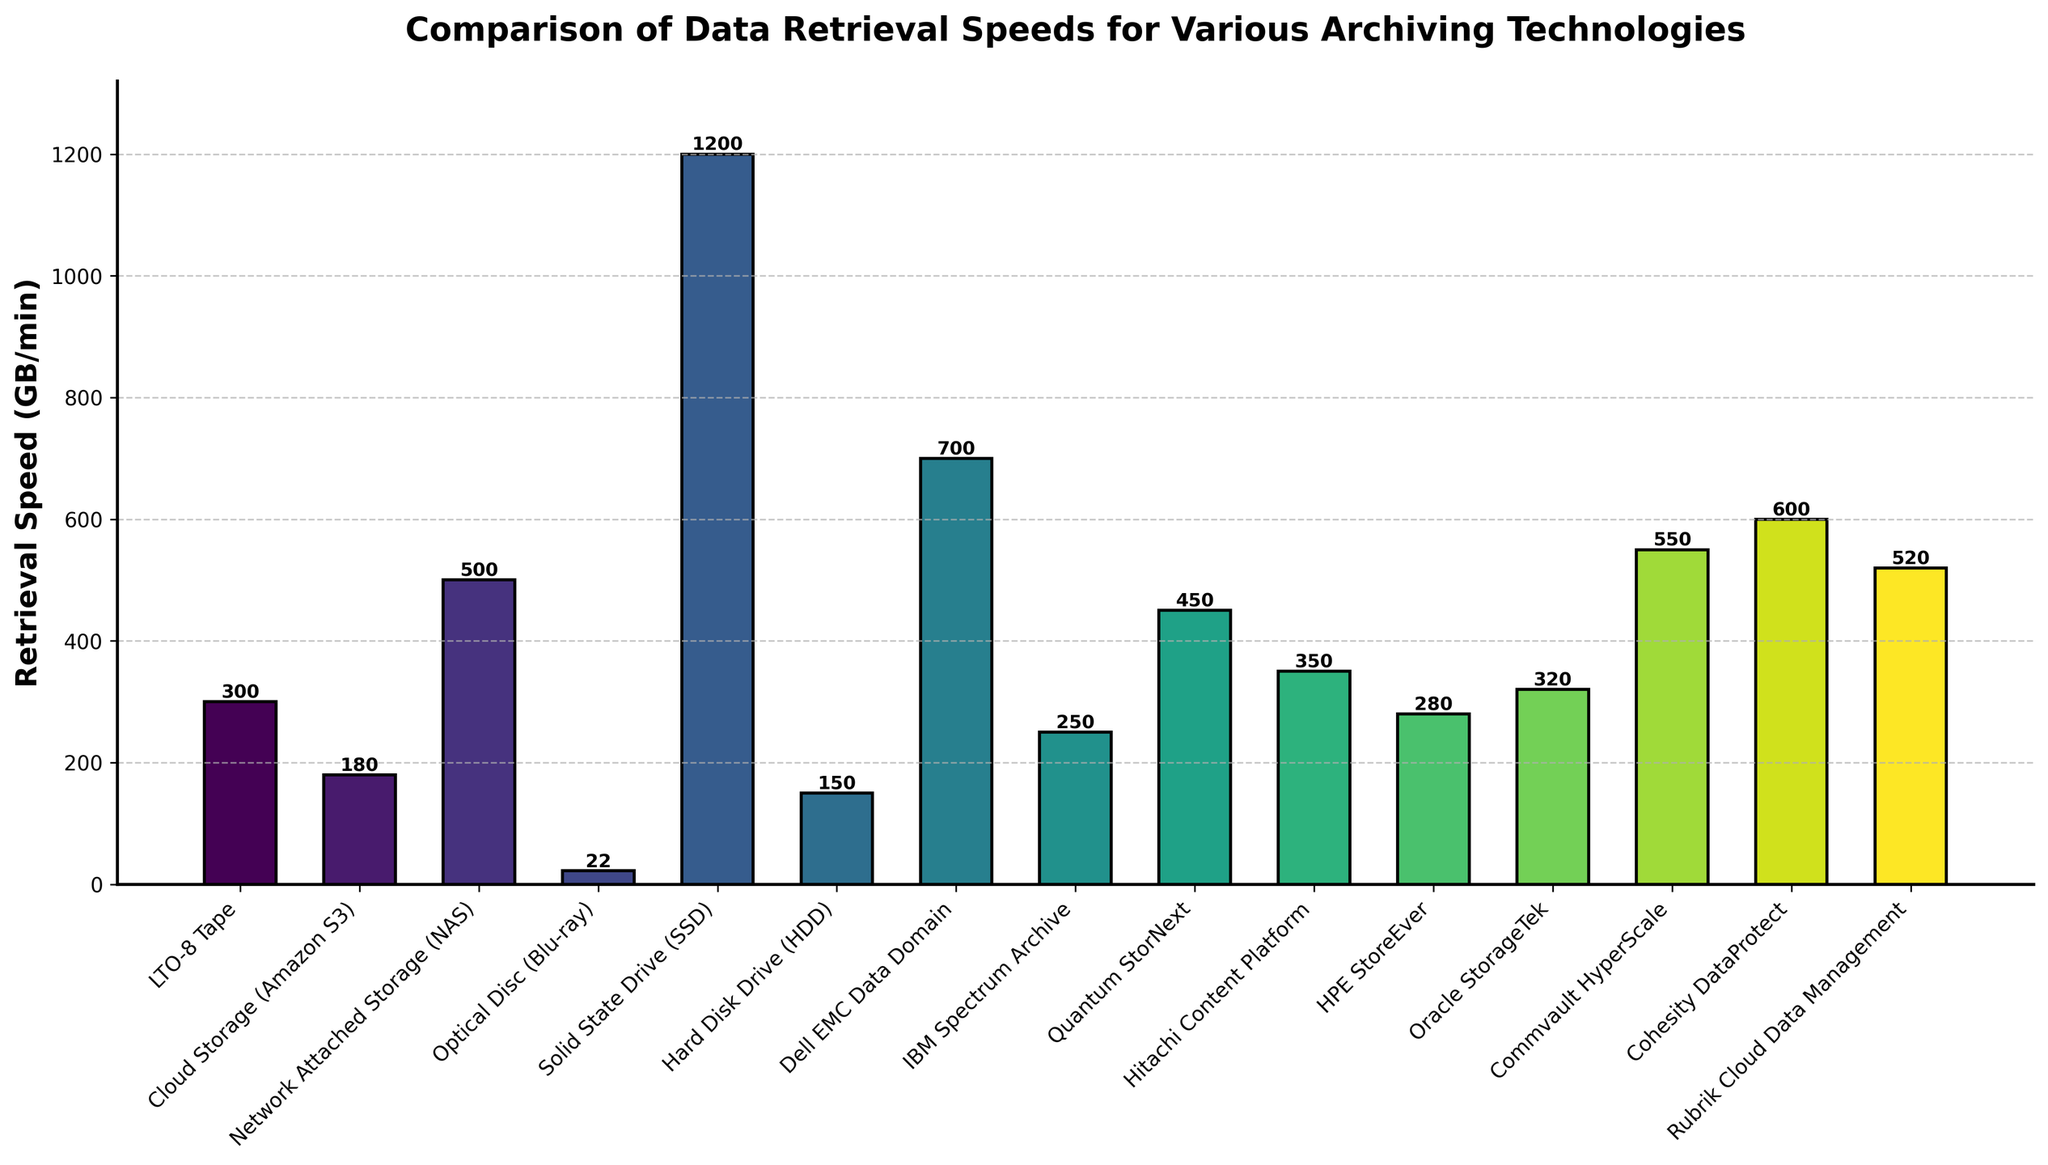What's the fastest data retrieval technology? The highest bar in the chart represents the fastest data retrieval technology. In this case, the Solid State Drive (SSD) has the tallest bar, indicating the highest retrieval speed.
Answer: Solid State Drive (SSD) What's the difference in retrieval speed between LTO-8 Tape and Cloud Storage (Amazon S3)? The LTO-8 Tape has a retrieval speed of 300 GB/min and Cloud Storage (Amazon S3) has 180 GB/min. The difference is calculated by subtracting the smaller value from the larger one (300 - 180).
Answer: 120 GB/min What is the average retrieval speed among all technologies? To find the average, sum all the retrieval speeds and divide by the number of technologies. The sum is (300 + 180 + 500 + 22 + 1200 + 150 + 700 + 250 + 450 + 350 + 280 + 320 + 550 + 600 + 520) = 6372. There are 15 technologies, so the average is 6372 / 15.
Answer: 424.8 GB/min Which technology has a slightly lower retrieval speed than Dell EMC Data Domain? Dell EMC Data Domain has a speed of 700 GB/min. By examining the bars, the closest lower value is Quantum StorNext at 450 GB/min but Cohesity DataProtect at 600 GB/min is slightly lower.
Answer: Cohesity DataProtect Which technology has the lowest retrieval speed and what is its value? The shortest bar in the chart represents the technology with the lowest retrieval speed. The Optical Disc (Blu-ray) is the shortest bar, with a retrieval speed.
Answer: 22 GB/min How many technologies have a retrieval speed greater than 400 GB/min? Count the number of bars that are taller than the one representing 400 GB/min. These are Network Attached Storage (NAS), Solid State Drive (SSD), Dell EMC Data Domain, Quantum StorNext, Commvault HyperScale, Cohesity DataProtect, and Rubrik Cloud Data Management.
Answer: 7 Which has a higher retrieval speed: IBM Spectrum Archive or Hitachi Content Platform? Comparing the heights of their respective bars, Hitachi Content Platform is slightly taller than IBM Spectrum Archive.
Answer: Hitachi Content Platform What is the combined retrieval speed of Solid State Drive (SSD) and Dell EMC Data Domain? The retrieval speeds are 1200 GB/min for SSD and 700 GB/min for Dell EMC Data Domain. Summing these up (1200 + 700) gives their combined retrieval speed.
Answer: 1900 GB/min What is the range of retrieval speeds among the technologies shown? The range is the difference between the highest and lowest retrieval speeds. The highest is from SSD (1200 GB/min) and the lowest is from Optical Disc (Blu-ray) (22 GB/min). Calculating the difference (1200 - 22) gives the range.
Answer: 1178 GB/min Which is greater: the sum of retrieval speeds of LTO-8 Tape, Cloud Storage (Amazon S3), and Optical Disc (Blu-ray) or the retrieval speed of Solid State Drive (SSD)? Sum the retrieval speeds of LTO-8 Tape (300 GB/min), Cloud Storage (Amazon S3) (180 GB/min), and Optical Disc (Blu-ray) (22 GB/min). The sum is (300 + 180 + 22) = 502 GB/min, which is less than the retrieval speed of SSD at 1200 GB/min.
Answer: Solid State Drive (SSD) 